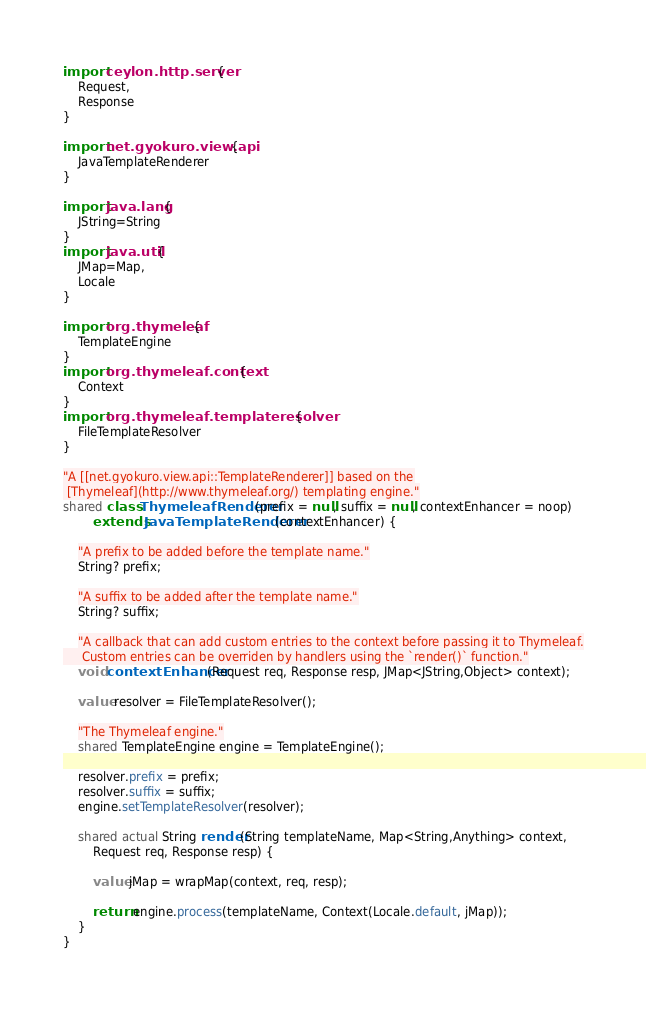<code> <loc_0><loc_0><loc_500><loc_500><_Ceylon_>import ceylon.http.server {
    Request,
    Response
}

import net.gyokuro.view.api {
    JavaTemplateRenderer
}

import java.lang {
    JString=String
}
import java.util {
    JMap=Map,
    Locale
}

import org.thymeleaf {
    TemplateEngine
}
import org.thymeleaf.context {
    Context
}
import org.thymeleaf.templateresolver {
    FileTemplateResolver
}

"A [[net.gyokuro.view.api::TemplateRenderer]] based on the
 [Thymeleaf](http://www.thymeleaf.org/) templating engine."
shared class ThymeleafRenderer(prefix = null, suffix = null, contextEnhancer = noop)
        extends JavaTemplateRenderer(contextEnhancer) {
    
    "A prefix to be added before the template name."
    String? prefix;
    
    "A suffix to be added after the template name."
    String? suffix;
    
    "A callback that can add custom entries to the context before passing it to Thymeleaf.
     Custom entries can be overriden by handlers using the `render()` function."
    void contextEnhancer(Request req, Response resp, JMap<JString,Object> context);
    
    value resolver = FileTemplateResolver();
    
    "The Thymeleaf engine."
    shared TemplateEngine engine = TemplateEngine();
    
    resolver.prefix = prefix;
    resolver.suffix = suffix;
    engine.setTemplateResolver(resolver);
    
    shared actual String render(String templateName, Map<String,Anything> context,
        Request req, Response resp) {
        
        value jMap = wrapMap(context, req, resp);
        
        return engine.process(templateName, Context(Locale.default, jMap));
    }
}
</code> 